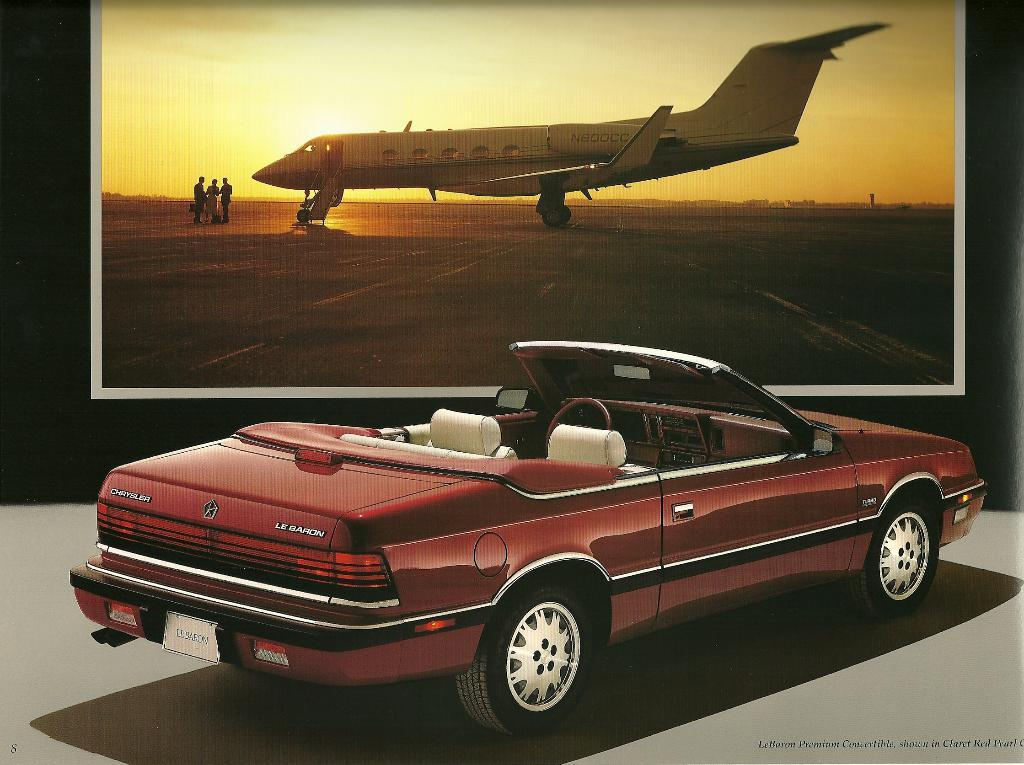Provide a one-sentence caption for the provided image. A convertible parked by a photo of an airplane has a license plate that says LEBARON. 